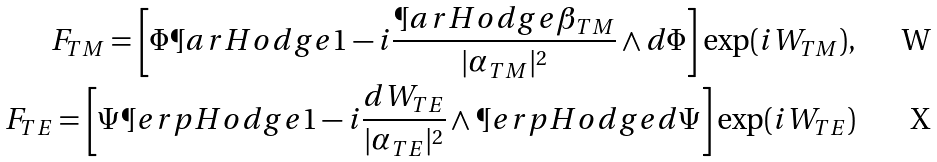<formula> <loc_0><loc_0><loc_500><loc_500>F _ { T M } = \left [ \Phi \P a r H o d g e 1 - i \frac { \P a r H o d g e \beta _ { T M } } { | \alpha _ { T M } | ^ { 2 } } \wedge d \Phi \right ] \exp ( i W _ { T M } ) , \\ F _ { T E } = \left [ \Psi \P e r p H o d g e 1 - i \frac { d W _ { T E } } { | \alpha _ { T E } | ^ { 2 } } \wedge \P e r p H o d g e d \Psi \right ] \exp ( i W _ { T E } )</formula> 